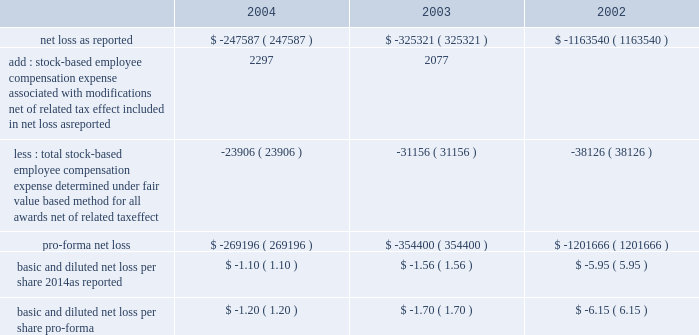American tower corporation and subsidiaries notes to consolidated financial statements 2014 ( continued ) stock-based compensation 2014the company complies with the provisions of sfas no .
148 , 201caccounting for stock-based compensation 2014transition and disclosure 2014an amendment of sfas no .
123 , 201d which provides optional transition guidance for those companies electing to voluntarily adopt the accounting provisions of sfas no .
123 .
The company continues to use accounting principles board opinion no .
25 ( apb no .
25 ) , 201caccounting for stock issued to employees , 201d to account for equity grants and awards to employees , officers and directors and has adopted the disclosure-only provisions of sfas no .
148 .
In accordance with apb no .
25 , the company recognizes compensation expense based on the excess , if any , of the quoted stock price at the grant date of the award or other measurement date over the amount an employee must pay to acquire the stock .
The company 2019s stock option plans are more fully described in note 13 .
In december 2004 , the fasb issued sfas no .
123r , 201cshare-based payment 201d ( sfas no .
123r ) , described below .
The table illustrates the effect on net loss and net loss per share if the company had applied the fair value recognition provisions of sfas no .
123 ( as amended ) to stock-based compensation .
The estimated fair value of each option is calculated using the black-scholes option-pricing model ( in thousands , except per share amounts ) : .
During the year ended december 31 , 2004 and 2003 , the company modified certain option awards to accelerate vesting and recorded charges of $ 3.0 million and $ 2.3 million , respectively , and corresponding increases to additional paid in capital in the accompanying consolidated financial statements .
Fair value of financial instruments 2014the carrying values of the company 2019s financial instruments , with the exception of long-term obligations , including current portion , reasonably approximate the related fair values as of december 31 , 2004 and 2003 .
As of december 31 , 2004 , the carrying amount and fair value of long-term obligations , including current portion , were $ 3.3 billion and $ 3.6 billion , respectively .
As of december 31 , 2003 , the carrying amount and fair value of long-term obligations , including current portion , were $ 3.4 billion and $ 3.6 billion , respectively .
Fair values are based primarily on quoted market prices for those or similar instruments .
Retirement plan 2014the company has a 401 ( k ) plan covering substantially all employees who meet certain age and employment requirements .
Under the plan , the company matching contribution for periods prior to june 30 , 2004 was 35% ( 35 % ) up to a maximum 5% ( 5 % ) of a participant 2019s contributions .
Effective july 1 , 2004 , the plan was amended to increase the company match to 50% ( 50 % ) up to a maximum 6% ( 6 % ) of a participant 2019s contributions .
The company contributed approximately $ 533000 , $ 825000 and $ 979000 to the plan for the years ended december 31 , 2004 , 2003 and 2002 , respectively .
Recent accounting pronouncements 2014in december 2004 , the fasb issued sfas no .
123r , which is a revision of sfas no .
123 , 201caccounting for stock-based compensation , 201d and supersedes apb no .
25 , accounting for .
What was the percentage increase in the employee contribution from 2002 to 2003? 
Computations: ((825000 - 979000) / 979000)
Answer: -0.1573. 